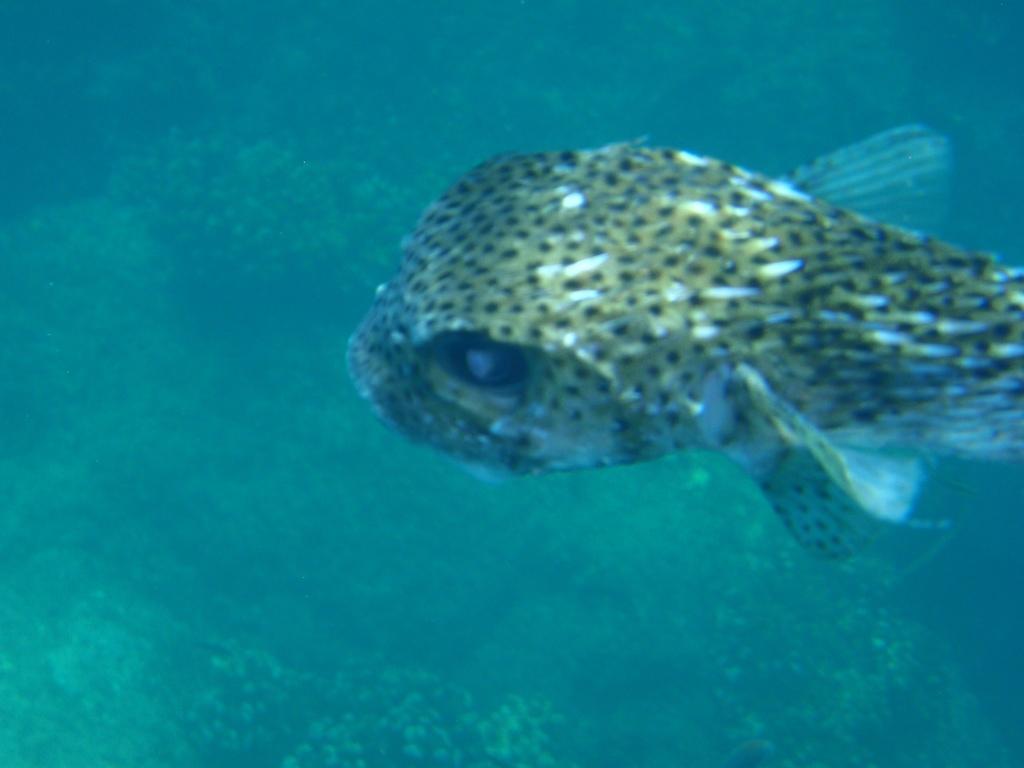Can you describe this image briefly? We can see a fish in the image and aquatic plants in the water. 